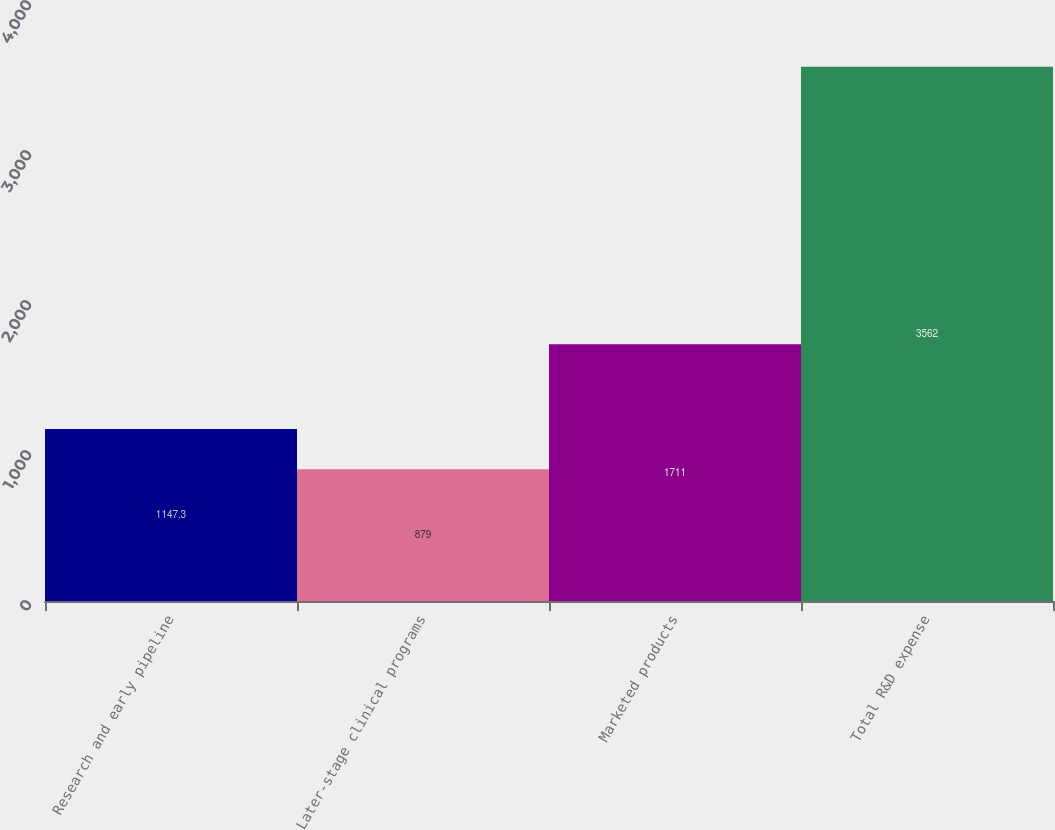<chart> <loc_0><loc_0><loc_500><loc_500><bar_chart><fcel>Research and early pipeline<fcel>Later-stage clinical programs<fcel>Marketed products<fcel>Total R&D expense<nl><fcel>1147.3<fcel>879<fcel>1711<fcel>3562<nl></chart> 